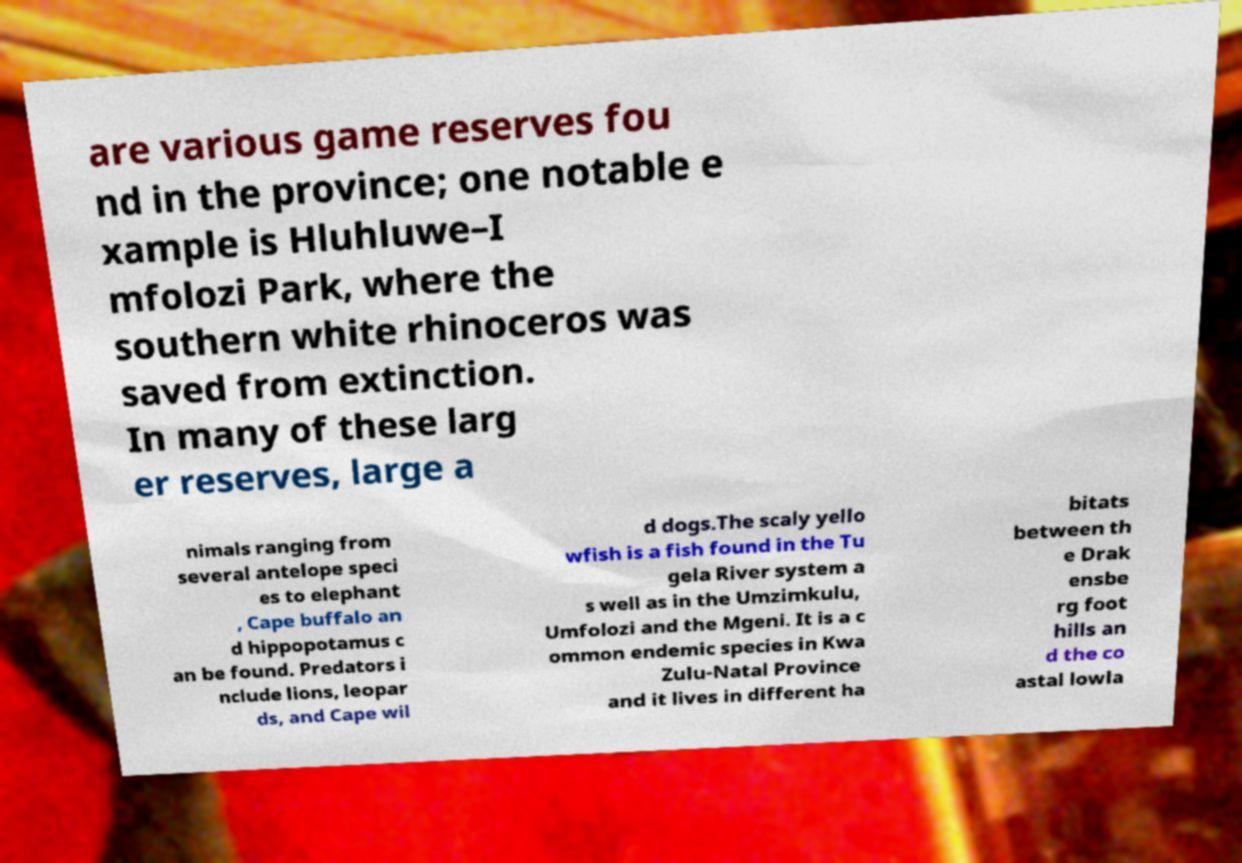For documentation purposes, I need the text within this image transcribed. Could you provide that? are various game reserves fou nd in the province; one notable e xample is Hluhluwe–I mfolozi Park, where the southern white rhinoceros was saved from extinction. In many of these larg er reserves, large a nimals ranging from several antelope speci es to elephant , Cape buffalo an d hippopotamus c an be found. Predators i nclude lions, leopar ds, and Cape wil d dogs.The scaly yello wfish is a fish found in the Tu gela River system a s well as in the Umzimkulu, Umfolozi and the Mgeni. It is a c ommon endemic species in Kwa Zulu-Natal Province and it lives in different ha bitats between th e Drak ensbe rg foot hills an d the co astal lowla 